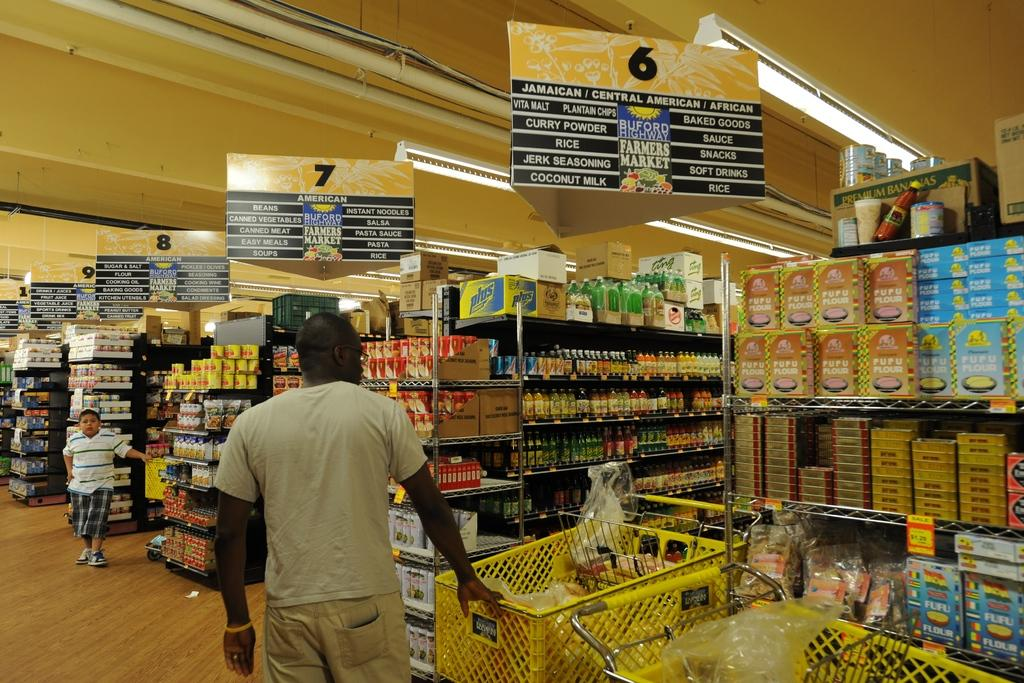<image>
Present a compact description of the photo's key features. the inside of a store showing the sign for aisle 6 